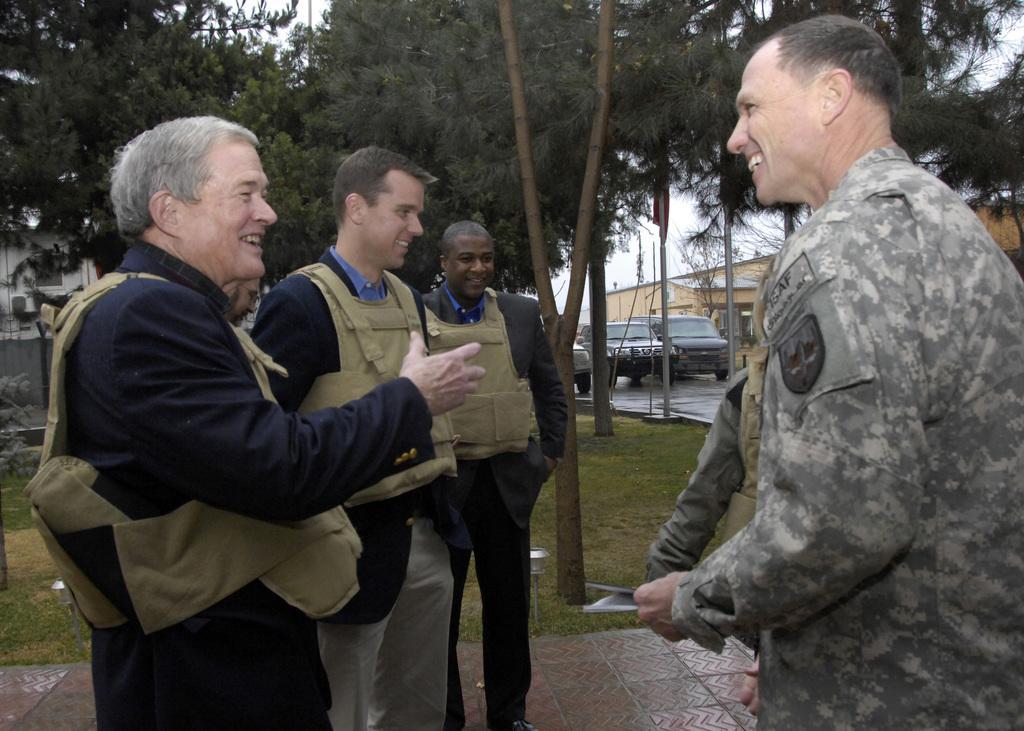Can you describe this image briefly? In this image we can see few vehicles. There is a grassy land in the image. There are few poles in the image. There is a sky in the image. There are few people in the image. A person is holding some object in his hand at the right side of the image. There are few houses in the image. 